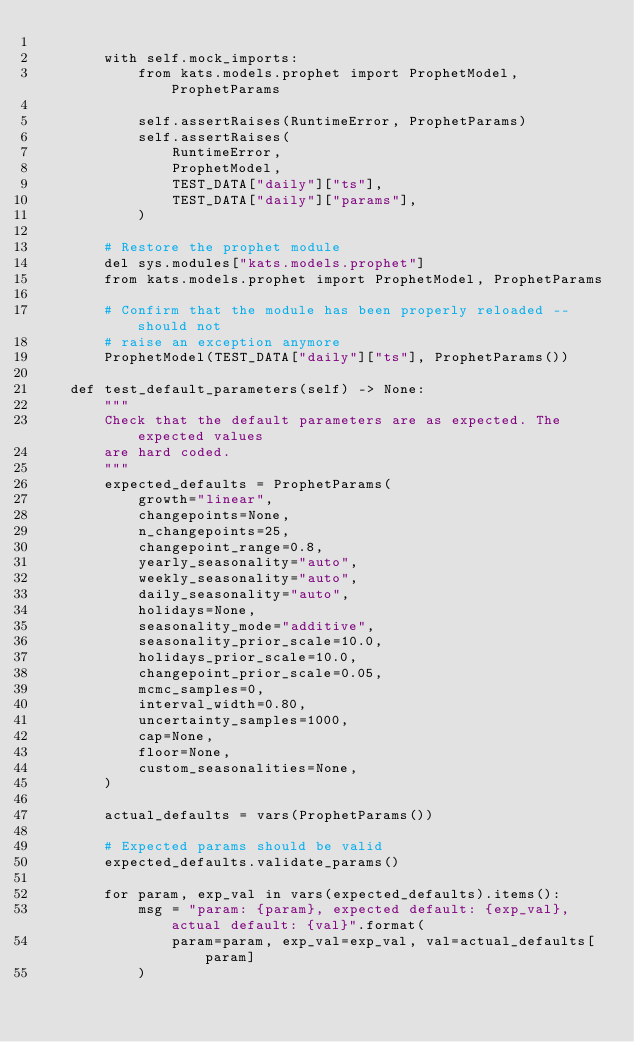Convert code to text. <code><loc_0><loc_0><loc_500><loc_500><_Python_>
        with self.mock_imports:
            from kats.models.prophet import ProphetModel, ProphetParams

            self.assertRaises(RuntimeError, ProphetParams)
            self.assertRaises(
                RuntimeError,
                ProphetModel,
                TEST_DATA["daily"]["ts"],
                TEST_DATA["daily"]["params"],
            )

        # Restore the prophet module
        del sys.modules["kats.models.prophet"]
        from kats.models.prophet import ProphetModel, ProphetParams

        # Confirm that the module has been properly reloaded -- should not
        # raise an exception anymore
        ProphetModel(TEST_DATA["daily"]["ts"], ProphetParams())

    def test_default_parameters(self) -> None:
        """
        Check that the default parameters are as expected. The expected values
        are hard coded.
        """
        expected_defaults = ProphetParams(
            growth="linear",
            changepoints=None,
            n_changepoints=25,
            changepoint_range=0.8,
            yearly_seasonality="auto",
            weekly_seasonality="auto",
            daily_seasonality="auto",
            holidays=None,
            seasonality_mode="additive",
            seasonality_prior_scale=10.0,
            holidays_prior_scale=10.0,
            changepoint_prior_scale=0.05,
            mcmc_samples=0,
            interval_width=0.80,
            uncertainty_samples=1000,
            cap=None,
            floor=None,
            custom_seasonalities=None,
        )

        actual_defaults = vars(ProphetParams())

        # Expected params should be valid
        expected_defaults.validate_params()

        for param, exp_val in vars(expected_defaults).items():
            msg = "param: {param}, expected default: {exp_val}, actual default: {val}".format(
                param=param, exp_val=exp_val, val=actual_defaults[param]
            )</code> 